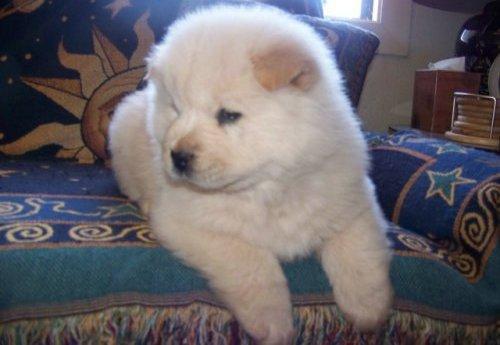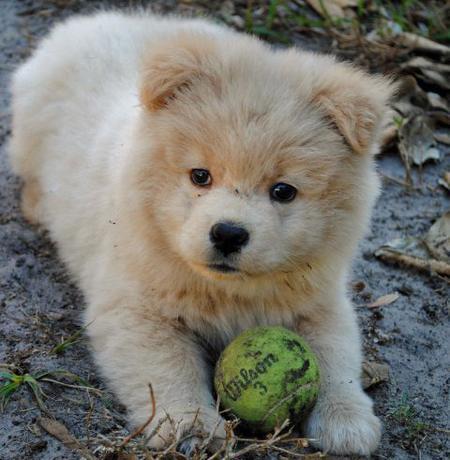The first image is the image on the left, the second image is the image on the right. For the images displayed, is the sentence "The combined images include two fluffy puppies with similar poses, expressions and colors." factually correct? Answer yes or no. Yes. The first image is the image on the left, the second image is the image on the right. For the images shown, is this caption "A single dog is standing on all fours in the image on the right." true? Answer yes or no. No. 